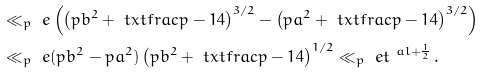<formula> <loc_0><loc_0><loc_500><loc_500>& \ll _ { p } \ e \left ( \left ( p b ^ { 2 } + \ t x t f r a c { p - 1 } 4 \right ) ^ { 3 / 2 } - \left ( p a ^ { 2 } + \ t x t f r a c { p - 1 } 4 \right ) ^ { 3 / 2 } \right ) \\ & \ll _ { p } \ e ( p b ^ { 2 } - p a ^ { 2 } ) \left ( p b ^ { 2 } + \ t x t f r a c { p - 1 } 4 \right ) ^ { 1 / 2 } \ll _ { p } \ e t ^ { \ a l + \frac { 1 } { 2 } } \, .</formula> 